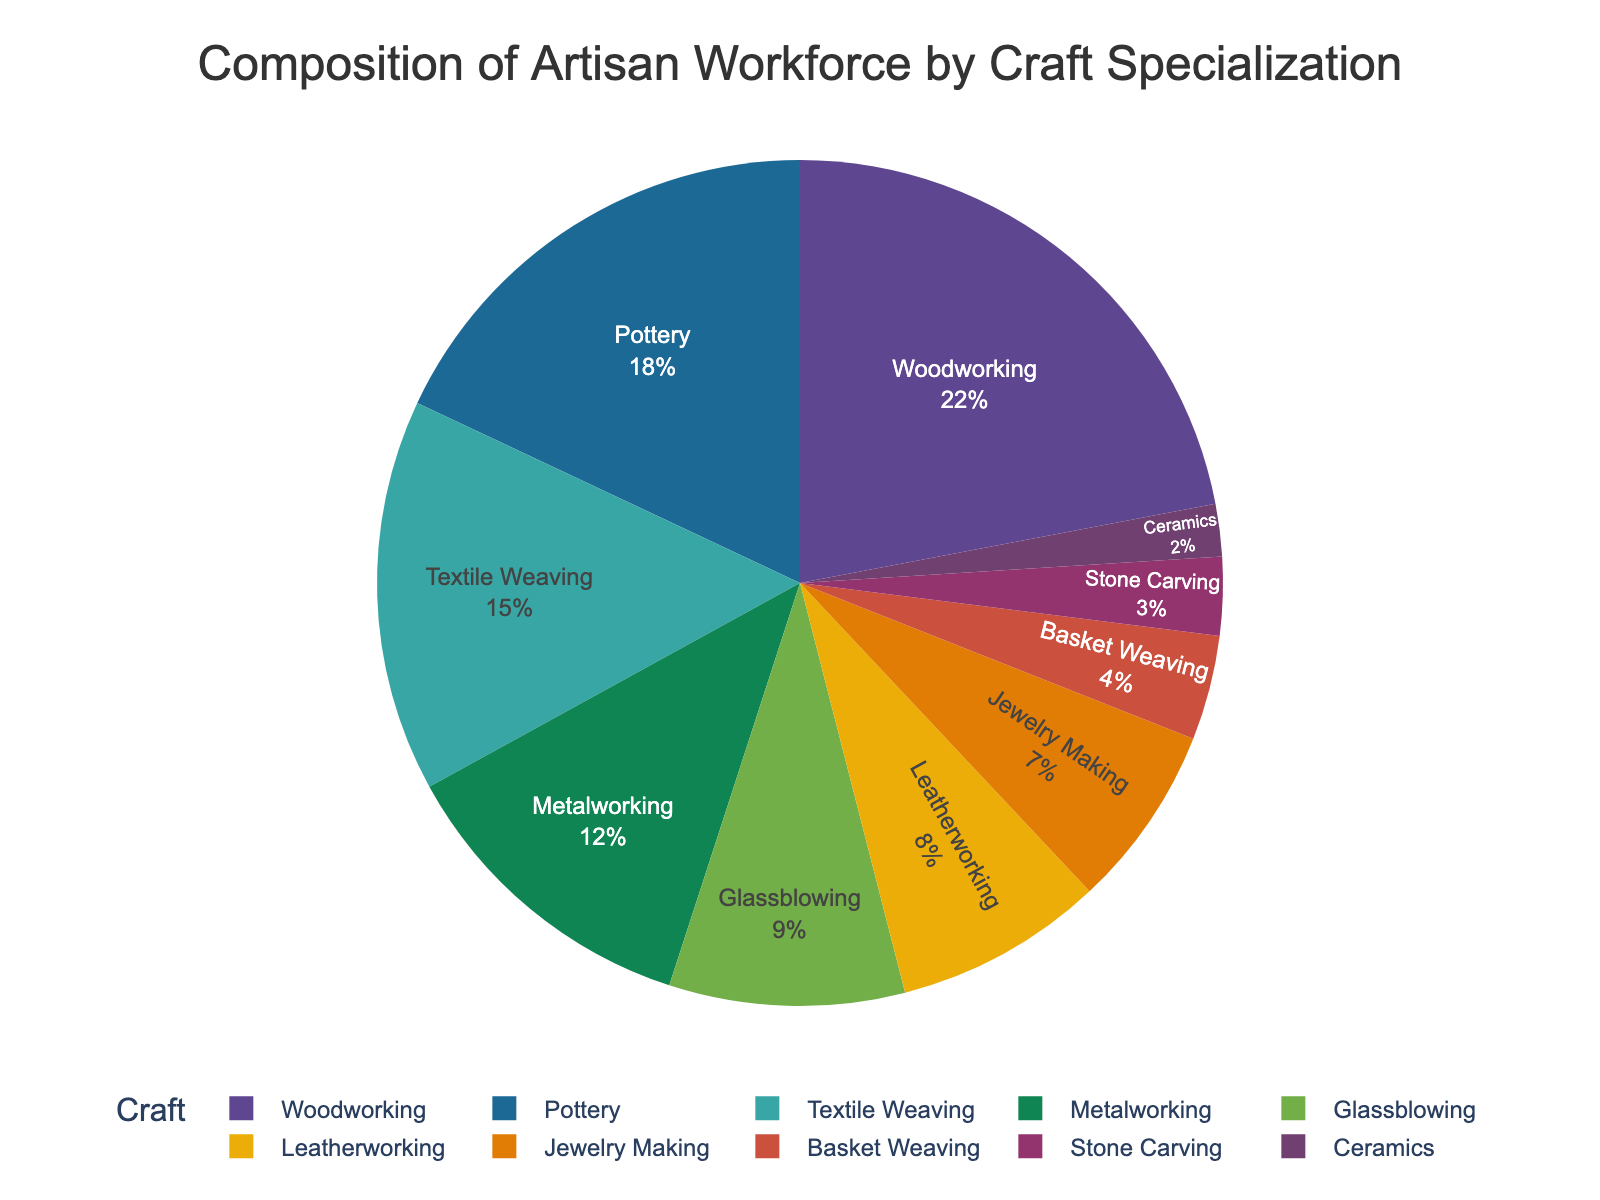What's the percentage of artisans involved in Woodworking and Pottery combined? To find the combined percentage, add the percentages for Woodworking (22%) and Pottery (18%): 22 + 18 = 40
Answer: 40% Which craft specialization has a higher percentage: Glassblowing or Leatherworking? Compare the percentages of Glassblowing (9%) and Leatherworking (8%). Since 9% is greater than 8%, Glassblowing has a higher percentage.
Answer: Glassblowing What is the difference in percentage between Textile Weaving and Stone Carving? Subtract the percentage of Stone Carving (3%) from Textile Weaving (15%): 15 - 3 = 12
Answer: 12% What crafts are shown in the darkest color on the pie chart? In a pie chart, typically darker colors are used for the crafts with larger percentages. Since Woodworking has the largest percentage (22%), it is likely shown in the darkest color.
Answer: Woodworking Is the percentage of artisans involved in Jewelry Making less than 10%? The percentage of artisans involved in Jewelry Making is 7%, which is less than 10%.
Answer: Yes How much larger is the percentage of artisans in Metalworking compared to Basket Weaving? Subtract the percentage of Basket Weaving (4%) from Metalworking (12%): 12 - 4 = 8
Answer: 8% What is the combined percentage of artisans in the three smallest craft specializations? The three smallest craft specializations are Ceramics (2%), Stone Carving (3%), and Basket Weaving (4%). Add their percentages: 2 + 3 + 4 = 9
Answer: 9% Which craft specialization has the lowest percentage, and what is that percentage? The specialization with the lowest percentage is Ceramics, which is 2%.
Answer: Ceramics, 2% Which two craft specializations are closest in percentage terms? The closest craft specializations are Leatherworking (8%) and Jewelry Making (7%), with a difference of 1%.
Answer: Leatherworking and Jewelry Making 